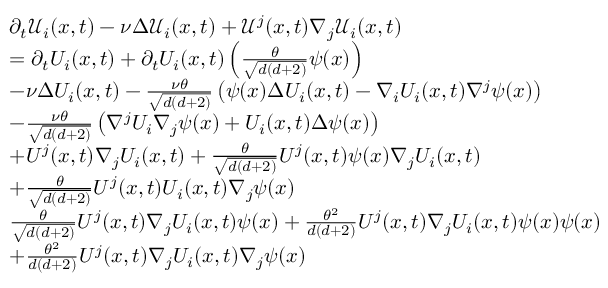Convert formula to latex. <formula><loc_0><loc_0><loc_500><loc_500>\begin{array} { r l } & { \partial _ { t } \mathcal { U } _ { i } ( x , t ) - \nu \Delta \mathcal { U } _ { i } ( x , t ) + \mathcal { U } ^ { j } ( x , t ) \nabla _ { j } \mathcal { U } _ { i } ( x , t ) } \\ & { = \partial _ { t } U _ { i } ( x , t ) + \partial _ { t } U _ { i } ( x , t ) \left ( \frac { \theta } { \sqrt { d ( d + 2 ) } } \psi ( x ) \right ) } \\ & { - \nu \Delta U _ { i } ( x , t ) - \frac { \nu \theta } { \sqrt { d ( d + 2 ) } } \left ( \psi ( x ) \Delta U _ { i } ( x , t ) - \nabla _ { i } U _ { i } ( x , t ) \nabla ^ { j } \psi ( x ) \right ) } \\ & { - \frac { \nu \theta } { \sqrt { d ( d + 2 ) } } \left ( \nabla ^ { j } U _ { i } \nabla _ { j } \psi ( x ) + U _ { i } ( x , t ) \Delta \psi ( x ) \right ) } \\ & { + U ^ { j } ( x , t ) \nabla _ { j } U _ { i } ( x , t ) + \frac { \theta } { \sqrt { d ( d + 2 ) } } U ^ { j } ( x , t ) \psi ( x ) \nabla _ { j } U _ { i } ( x , t ) } \\ & { + \frac { \theta } { \sqrt { d ( d + 2 ) } } U ^ { j } ( x , t ) U _ { i } ( x , t ) \nabla _ { j } \psi ( x ) } \\ & { \frac { \theta } { \sqrt { d ( d + 2 ) } } U ^ { j } ( x , t ) \nabla _ { j } U _ { i } ( x , t ) \psi ( x ) + \frac { \theta ^ { 2 } } { d ( d + 2 ) } U ^ { j } ( x , t ) \nabla _ { j } U _ { i } ( x , t ) \psi ( x ) \psi ( x ) } \\ & { + \frac { \theta ^ { 2 } } { d ( d + 2 ) } U ^ { j } ( x , t ) \nabla _ { j } U _ { i } ( x , t ) \nabla _ { j } \psi ( x ) } \end{array}</formula> 